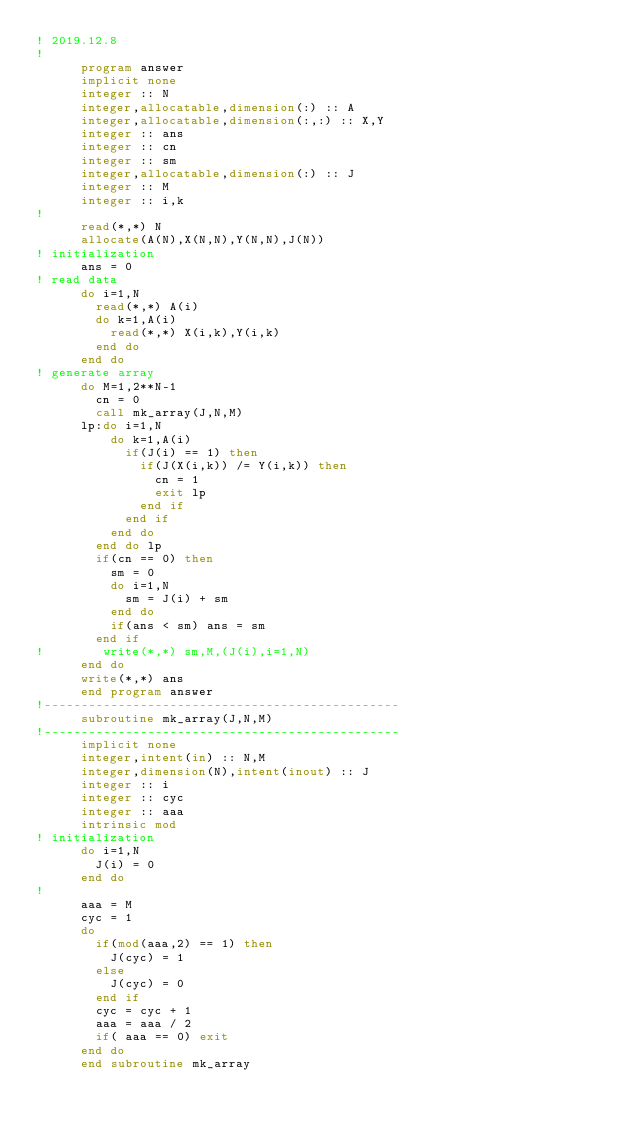Convert code to text. <code><loc_0><loc_0><loc_500><loc_500><_FORTRAN_>! 2019.12.8
!
      program answer
      implicit none
      integer :: N
      integer,allocatable,dimension(:) :: A
      integer,allocatable,dimension(:,:) :: X,Y
      integer :: ans
      integer :: cn
      integer :: sm
      integer,allocatable,dimension(:) :: J
      integer :: M
      integer :: i,k
!
      read(*,*) N
      allocate(A(N),X(N,N),Y(N,N),J(N))
! initialization
      ans = 0
! read data
      do i=1,N
        read(*,*) A(i)
        do k=1,A(i)
          read(*,*) X(i,k),Y(i,k)
        end do
      end do
! generate array
      do M=1,2**N-1
        cn = 0
        call mk_array(J,N,M)
      lp:do i=1,N
          do k=1,A(i)
            if(J(i) == 1) then
              if(J(X(i,k)) /= Y(i,k)) then
                cn = 1
                exit lp
              end if
            end if
          end do
        end do lp
        if(cn == 0) then
          sm = 0
          do i=1,N
            sm = J(i) + sm
          end do
          if(ans < sm) ans = sm
        end if
!        write(*,*) sm,M,(J(i),i=1,N)
      end do
      write(*,*) ans
      end program answer
!------------------------------------------------
      subroutine mk_array(J,N,M)
!------------------------------------------------
      implicit none
      integer,intent(in) :: N,M
      integer,dimension(N),intent(inout) :: J
      integer :: i
      integer :: cyc
      integer :: aaa
      intrinsic mod
! initialization
      do i=1,N
        J(i) = 0
      end do
! 
      aaa = M
      cyc = 1
      do
        if(mod(aaa,2) == 1) then
          J(cyc) = 1
        else
          J(cyc) = 0
        end if
        cyc = cyc + 1
        aaa = aaa / 2
        if( aaa == 0) exit
      end do
      end subroutine mk_array</code> 